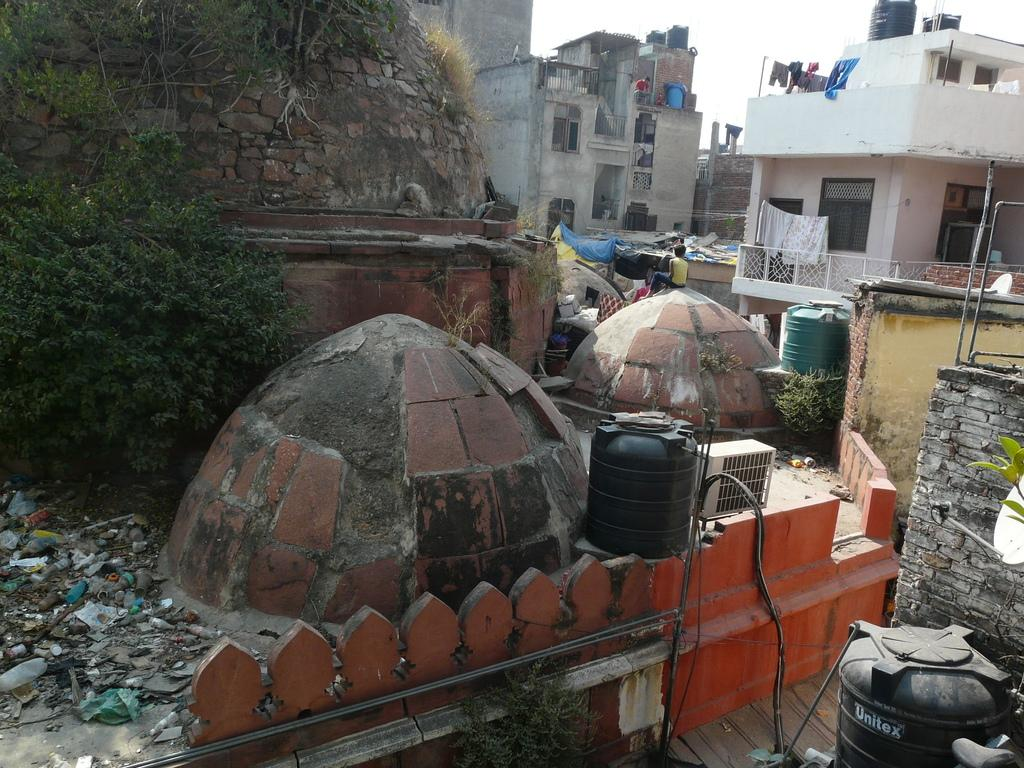What type of structures can be seen in the image? There are buildings in the image. What natural elements are present in the image? There are trees and rocks in the image. What man-made objects can be seen in the image? There are water tanks and a railing in the image. What is visible in the sky in the image? There is sky visible in the image. What are the people in the image doing? There are people in the image, but their activities are not specified. What can be used for drying or storing clothes in the image? There are clothes in the image, but no specific drying or storage apparatus is mentioned. What type of shoe can be seen on fire in the image? There is no shoe present in the image, let alone one on fire. What book is being read by the rocks in the image? There is no book present in the image, and rocks are not capable of reading. 